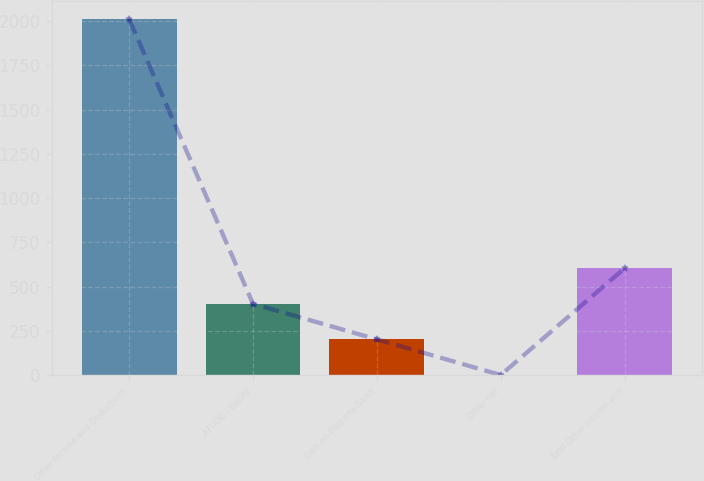Convert chart to OTSL. <chart><loc_0><loc_0><loc_500><loc_500><bar_chart><fcel>Other Income and Deductions<fcel>AFUDC - Equity<fcel>Gain on Property Sales<fcel>Other net<fcel>Total Other Income and<nl><fcel>2011<fcel>402.92<fcel>201.91<fcel>0.9<fcel>603.93<nl></chart> 